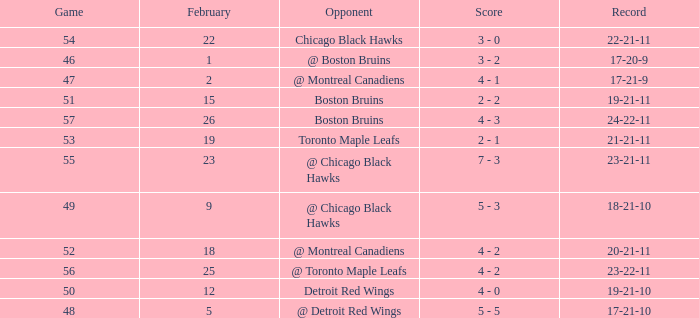What was the score of the game 57 after February 23? 4 - 3. 